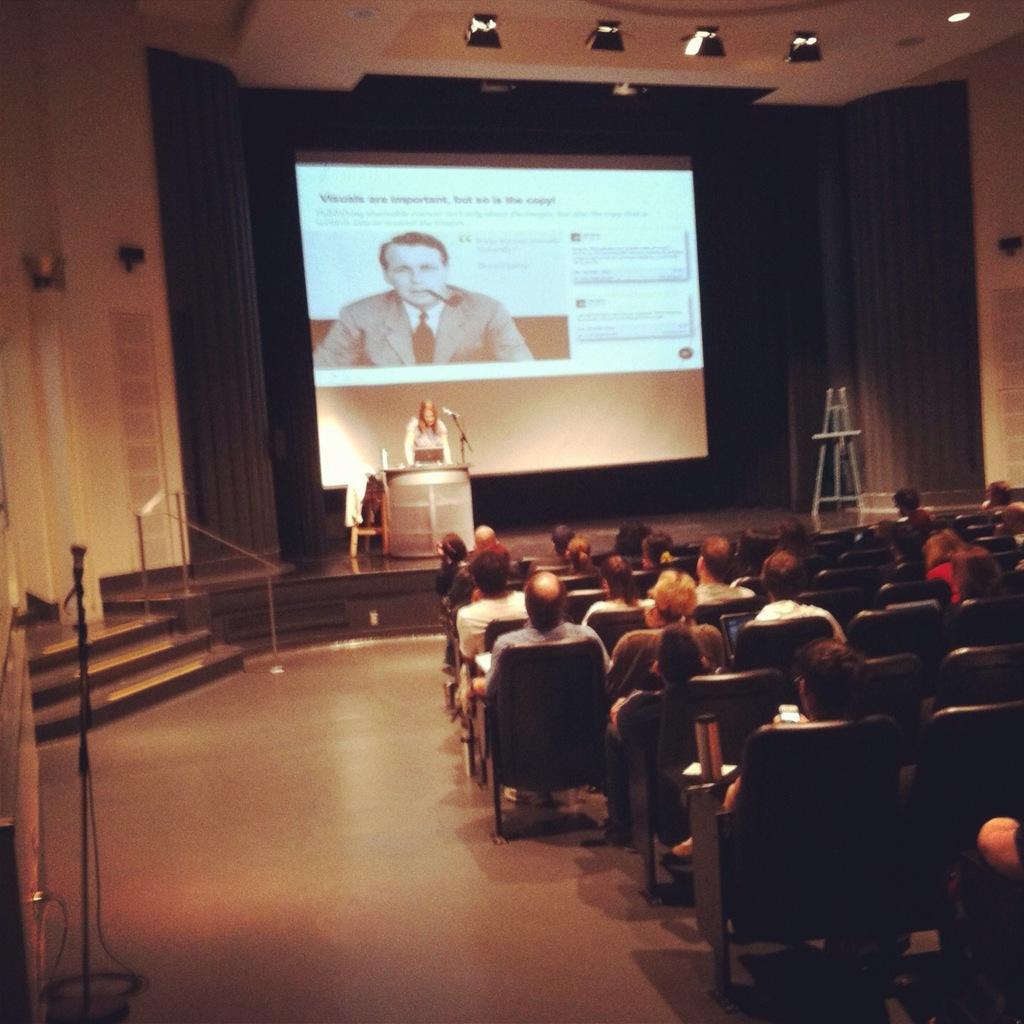How would you summarize this image in a sentence or two? A picture of a auditorium. Far there is a screen, on this screen there is a person wore suit and tie. On this stage there is a podium and person is standing. Few persons are sitting on chairs. On top there are lights. 